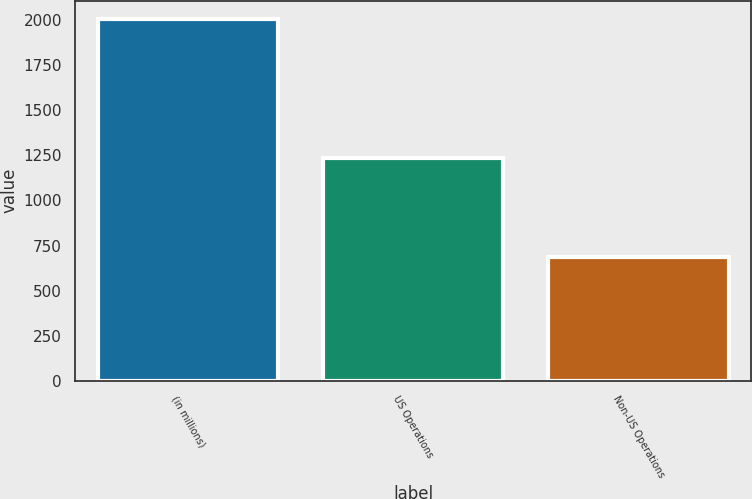<chart> <loc_0><loc_0><loc_500><loc_500><bar_chart><fcel>(in millions)<fcel>US Operations<fcel>Non-US Operations<nl><fcel>2008<fcel>1236.9<fcel>685.2<nl></chart> 